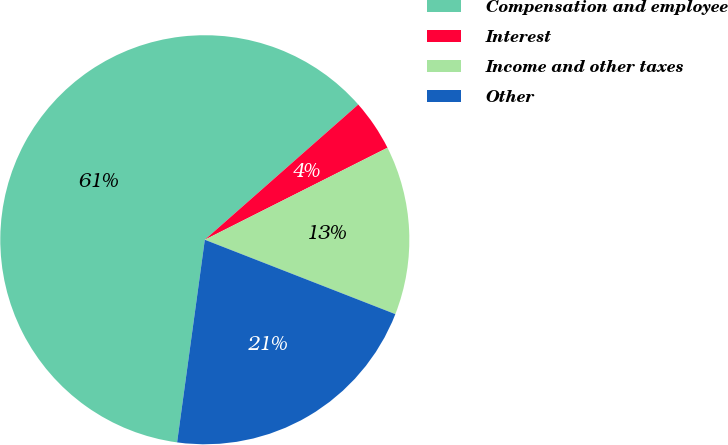Convert chart. <chart><loc_0><loc_0><loc_500><loc_500><pie_chart><fcel>Compensation and employee<fcel>Interest<fcel>Income and other taxes<fcel>Other<nl><fcel>61.34%<fcel>4.07%<fcel>13.35%<fcel>21.24%<nl></chart> 